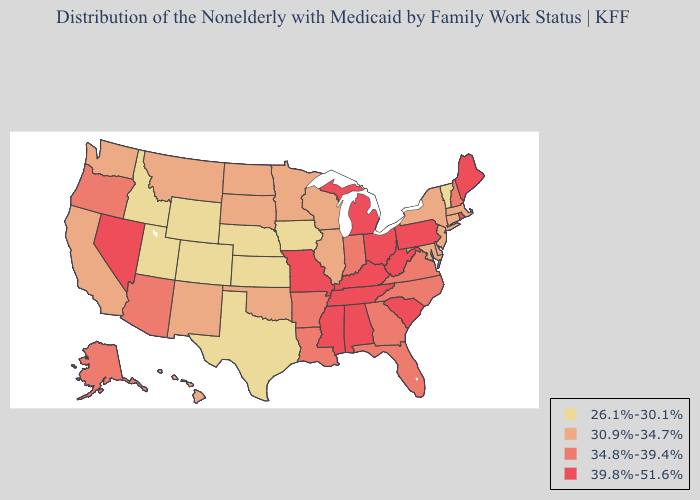Among the states that border Mississippi , which have the lowest value?
Short answer required. Arkansas, Louisiana. What is the value of Montana?
Concise answer only. 30.9%-34.7%. Does Louisiana have a lower value than South Carolina?
Give a very brief answer. Yes. Name the states that have a value in the range 34.8%-39.4%?
Concise answer only. Alaska, Arizona, Arkansas, Florida, Georgia, Indiana, Louisiana, New Hampshire, North Carolina, Oregon, Virginia. Is the legend a continuous bar?
Keep it brief. No. Which states hav the highest value in the West?
Give a very brief answer. Nevada. Name the states that have a value in the range 26.1%-30.1%?
Give a very brief answer. Colorado, Idaho, Iowa, Kansas, Nebraska, Texas, Utah, Vermont, Wyoming. Name the states that have a value in the range 30.9%-34.7%?
Answer briefly. California, Connecticut, Delaware, Hawaii, Illinois, Maryland, Massachusetts, Minnesota, Montana, New Jersey, New Mexico, New York, North Dakota, Oklahoma, South Dakota, Washington, Wisconsin. What is the value of Connecticut?
Keep it brief. 30.9%-34.7%. What is the value of Kentucky?
Quick response, please. 39.8%-51.6%. What is the highest value in states that border Mississippi?
Concise answer only. 39.8%-51.6%. What is the lowest value in the MidWest?
Write a very short answer. 26.1%-30.1%. What is the value of Pennsylvania?
Write a very short answer. 39.8%-51.6%. Does Kentucky have the highest value in the USA?
Concise answer only. Yes. Name the states that have a value in the range 26.1%-30.1%?
Concise answer only. Colorado, Idaho, Iowa, Kansas, Nebraska, Texas, Utah, Vermont, Wyoming. 